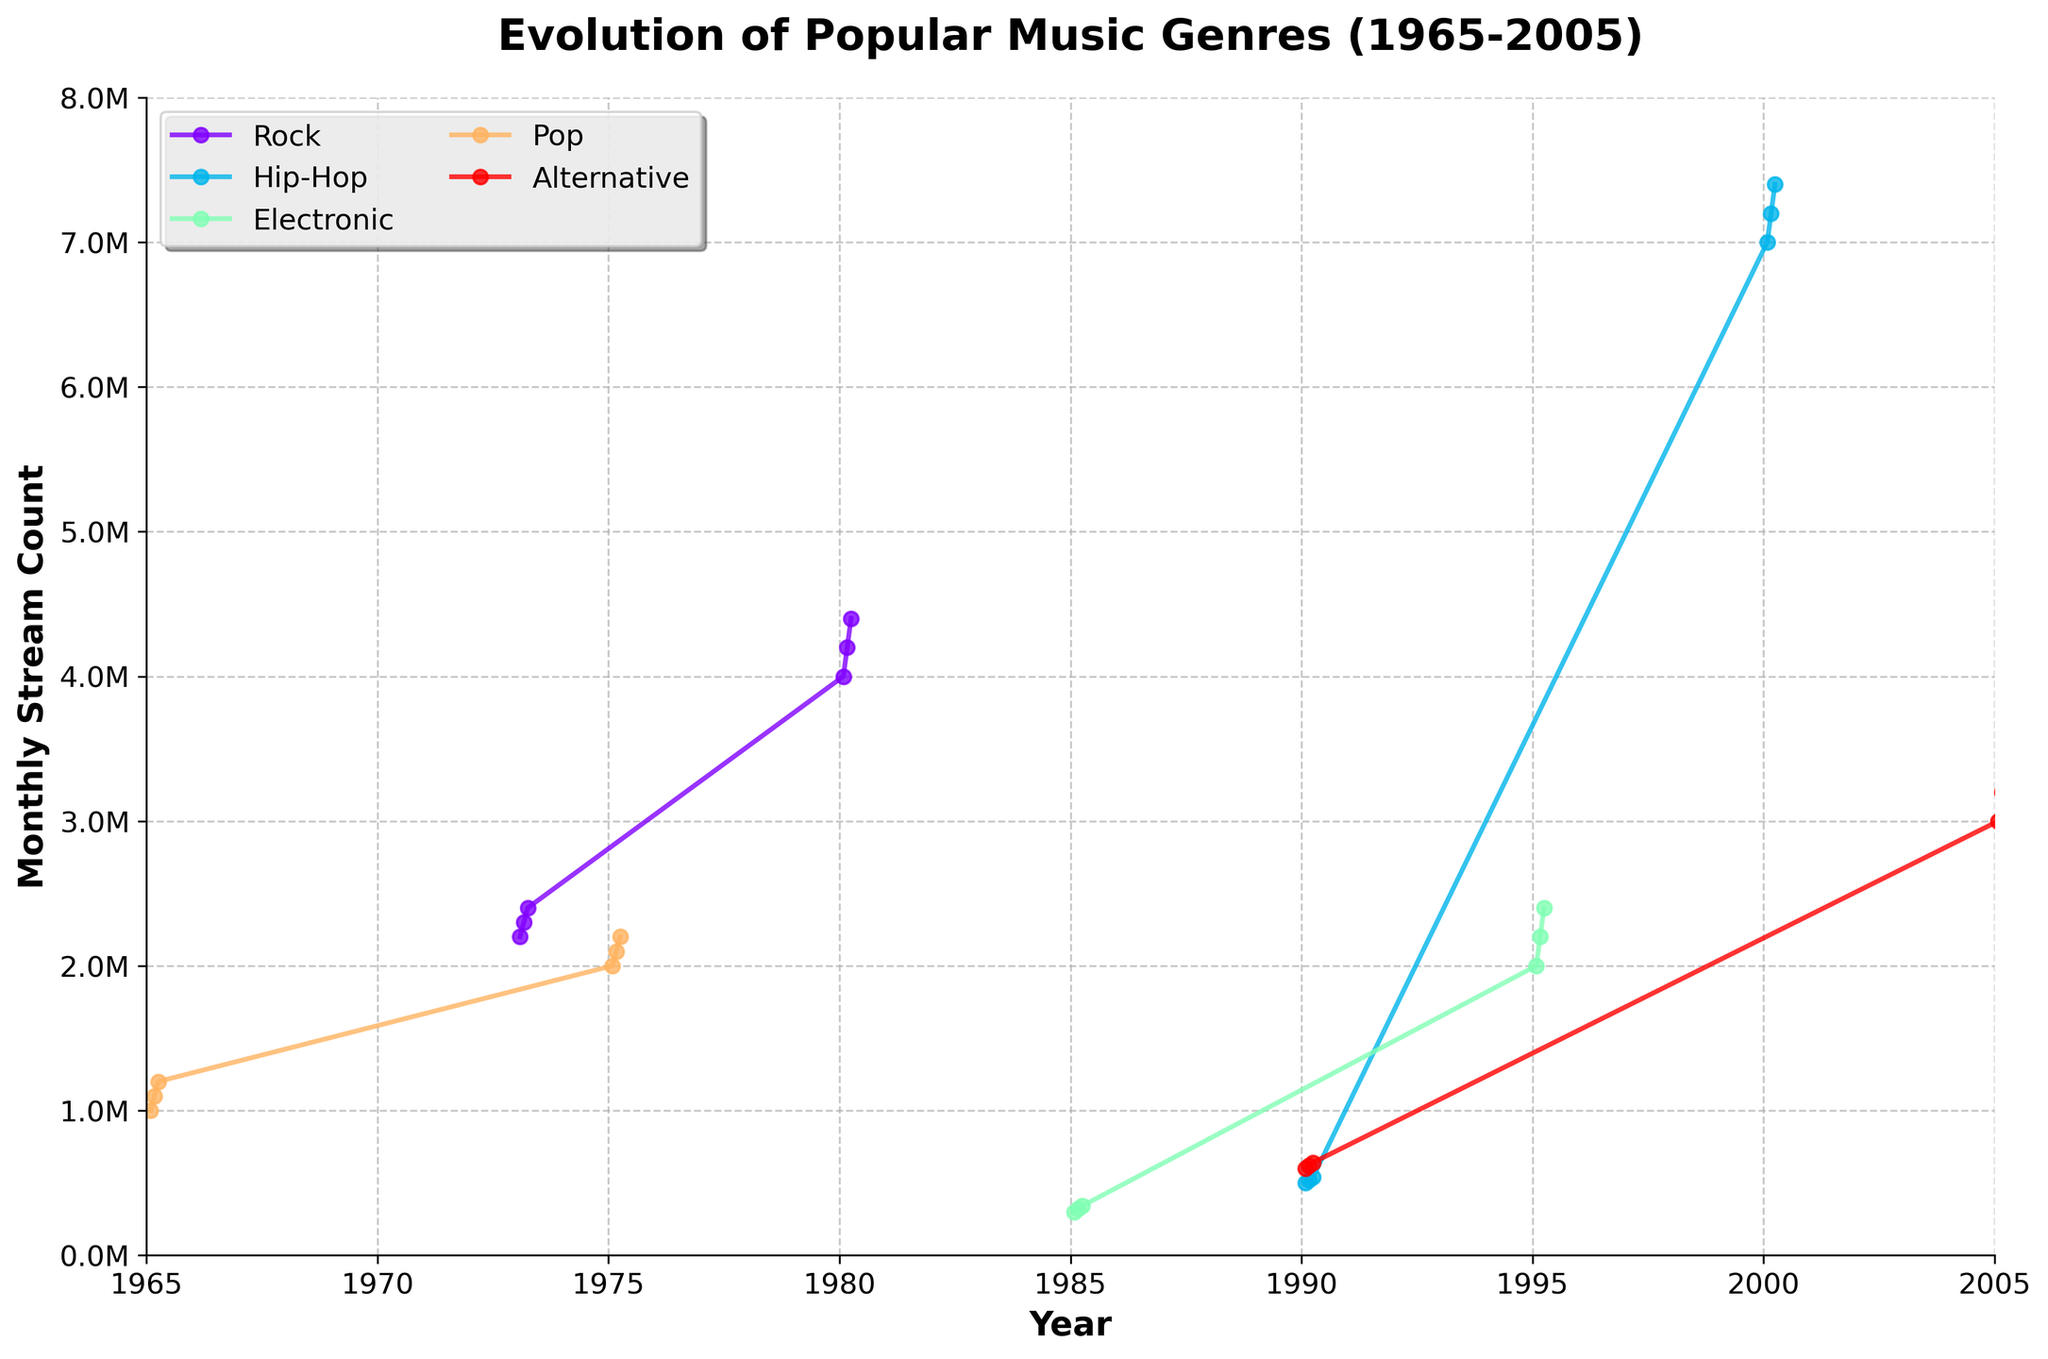Which genre shows the most consistent rise in stream count over time? By examining the plot, look at the trend lines for all genres. Rock and Pop show a consistent gradual rise over their respective periods, but Pop seems more linear and steady throughout.
Answer: Pop How many genres are tracked in this plot? Count the number of distinct colored lines with different labels on the figure. There are five lines labeled for Pop, Rock, Hip-Hop, Electronic, and Alternative.
Answer: 5 Which genre had the highest stream count in 2000? Identify the genre that reaches its peak in 2000. According to the data, Hip-Hop peaks in 2000, with the highest stream counts around 7.4 million.
Answer: Hip-Hop What is the stream count difference for Rock between 1973 and 1980? Look at the stream counts for Rock in 1973 and 1980. In 1973, it goes from 2.2M to 2.4M, and in 1980, it ranges between 4M to 4.4M. Taking the midpoints: (4M - 2.3M) = 1.7M
Answer: 1.7M Which genre was introduced the latest according to the plot? Find the genre with the latest starting year in the plot. Alternative starts in 1990 while other genres start earlier.
Answer: Alternative Between Pop and Electronic, which genre shows greater variability in stream counts? Compare the variation in the vertical spread of the lines. Pop shows less spread whereas Electronic shows a noticeable jump from thousands to over 2 million counts.
Answer: Electronic What is the average stream count for Hip-Hop in 1990? Sum the stream counts for Hip-Hop in 1990 and divide by the number of months. (500k + 520k + 540k) / 3 = 1.56M / 3 = 0.52M
Answer: 0.52M Which two genres have overlapping periods with significant stream count increase? Look for lines that overlap in years and show substantial streaming increments. Electronic (1985-1995) and Hip-Hop (1990-2000) overlap in the early 1990s with noticeable increases.
Answer: Electronic and Hip-Hop How did the stream count for Pop change from 1965 to 1975? Examine the change in stream counts over time. In 1965, it goes from 1M to 1.2M, and in 1975, it ranges between 2M to 2.2M. Calculate the difference: (2.1M - 1.1M) = 1M
Answer: 1M What is the overall trend for the Electronic genre? Follow the line for the Electronic genre. It shows an initial low stream count around 1985 and then a major increase around 1995.
Answer: Increasing trend 